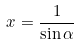Convert formula to latex. <formula><loc_0><loc_0><loc_500><loc_500>x = \frac { 1 } { \sin \alpha }</formula> 